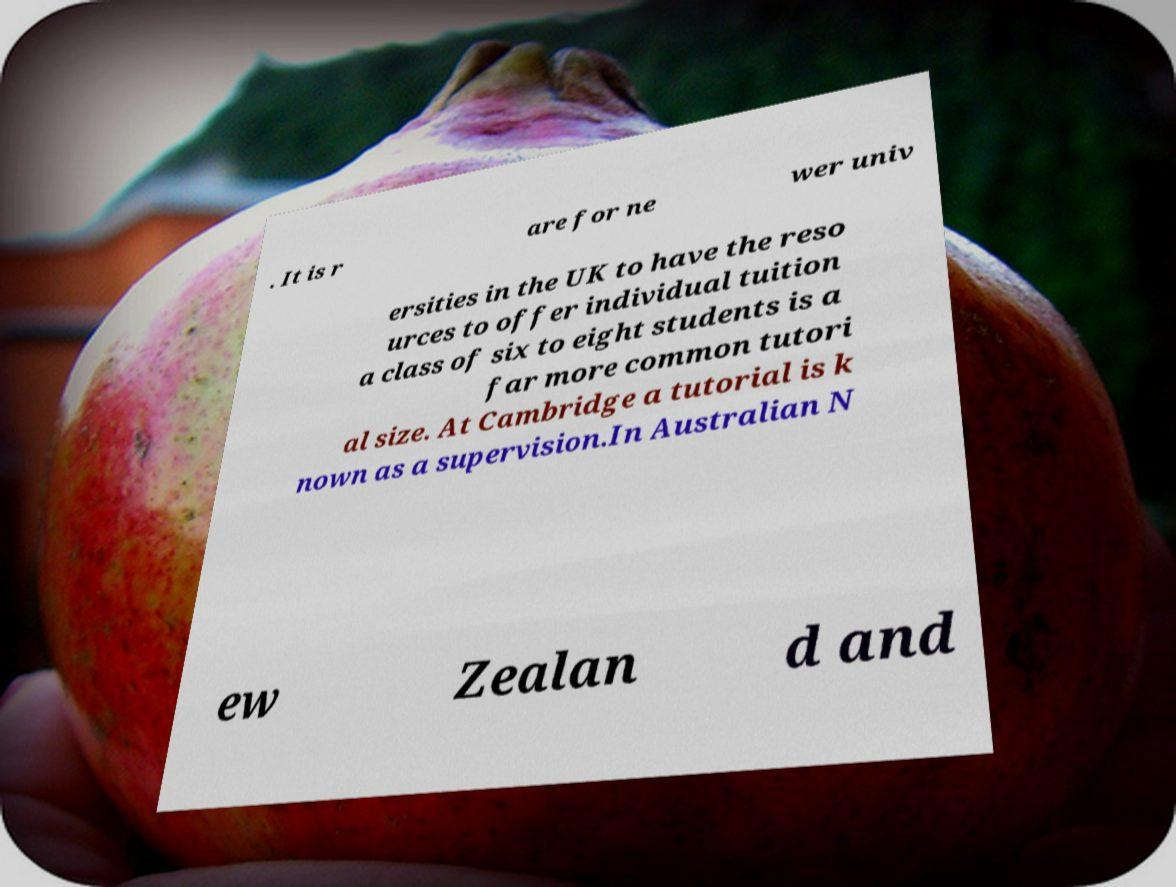I need the written content from this picture converted into text. Can you do that? . It is r are for ne wer univ ersities in the UK to have the reso urces to offer individual tuition a class of six to eight students is a far more common tutori al size. At Cambridge a tutorial is k nown as a supervision.In Australian N ew Zealan d and 